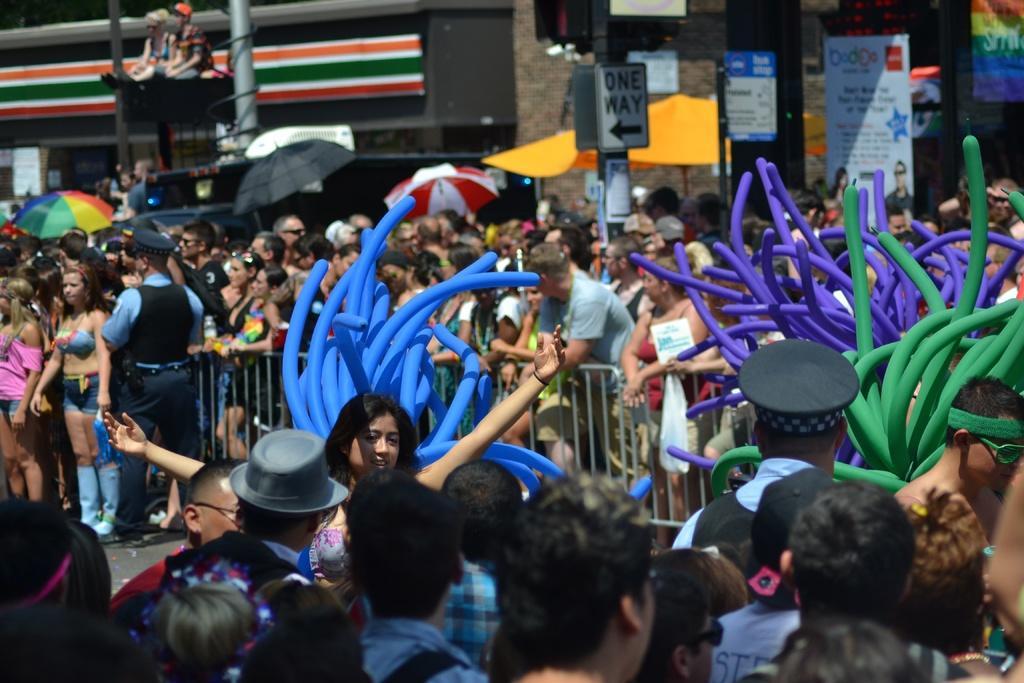Can you describe this image briefly? In this image there are people standing, in the middle there is a railing and there are umbrellas and balloons, in the background there is building and boards, on that boards there is some text. 